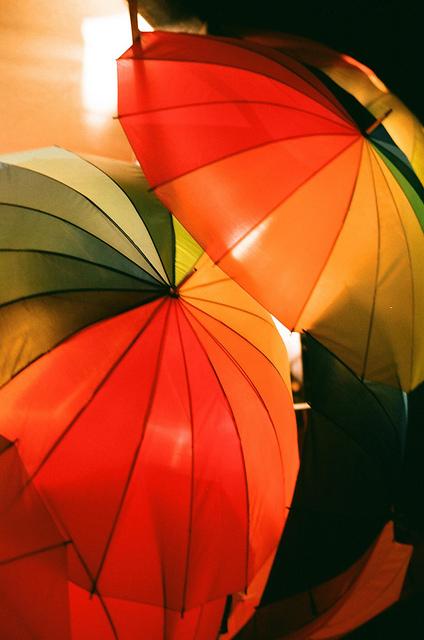Are the umbrellas open?
Quick response, please. Yes. Are these umbrellas?
Write a very short answer. Yes. Are the umbrellas all pink?
Concise answer only. No. 